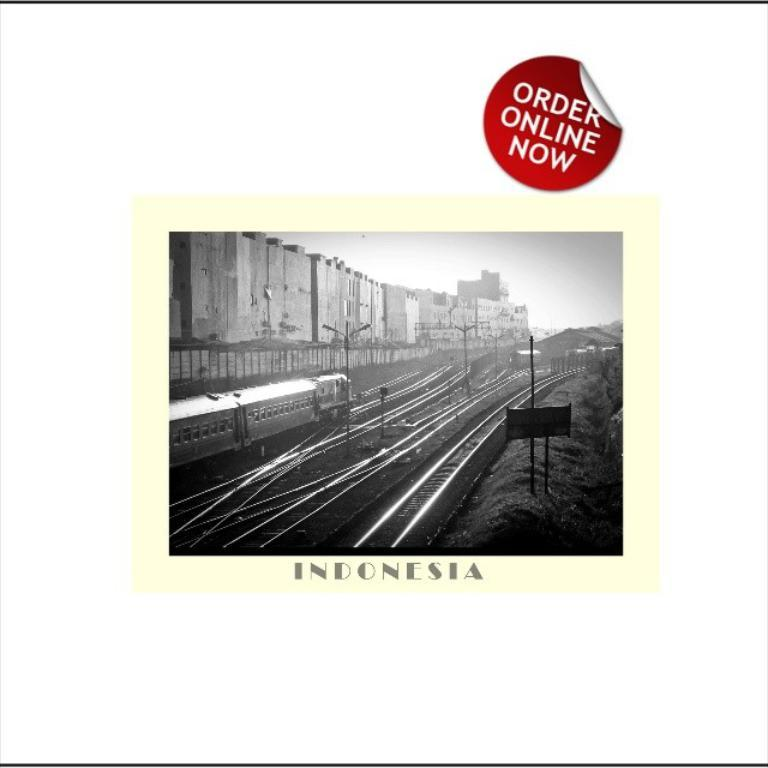<image>
Relay a brief, clear account of the picture shown. an indonesia paper that has an order online now sign 